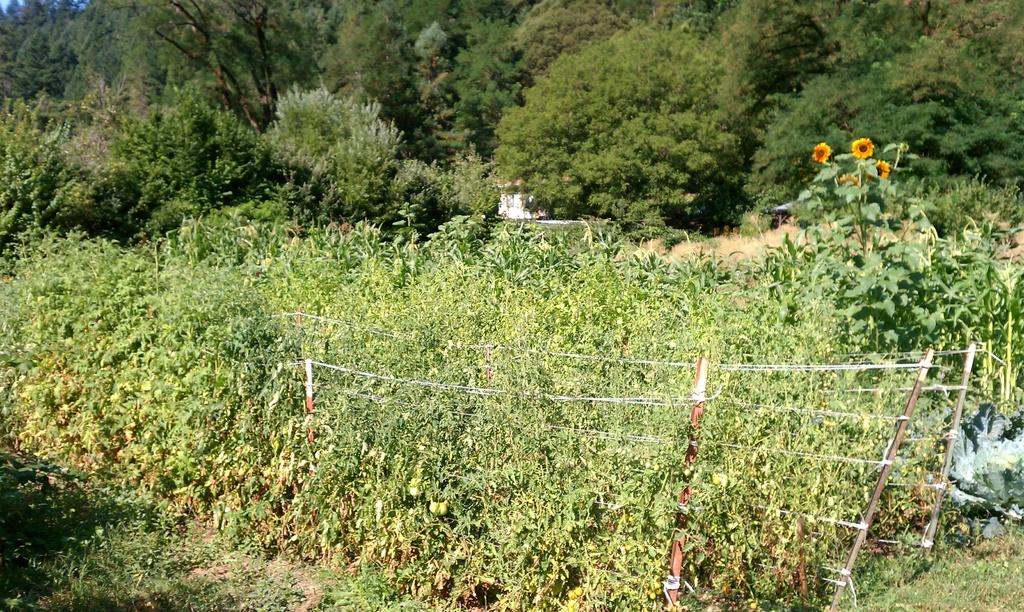What type of vegetation can be seen in the image? There are trees, plants, grass, and flowers in the image. What kind of barrier is present in the image? There is a fence in the image. How much honey can be seen dripping from the flowers in the image? There is no honey present in the image; it only features flowers, trees, plants, grass, and a fence. 